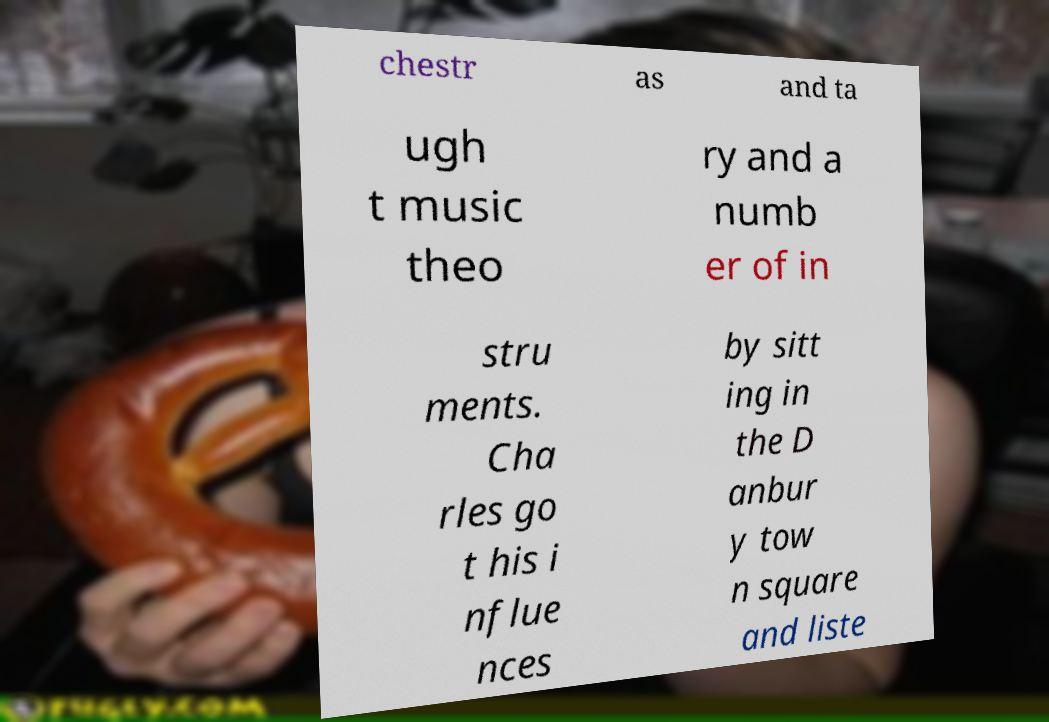Can you accurately transcribe the text from the provided image for me? chestr as and ta ugh t music theo ry and a numb er of in stru ments. Cha rles go t his i nflue nces by sitt ing in the D anbur y tow n square and liste 